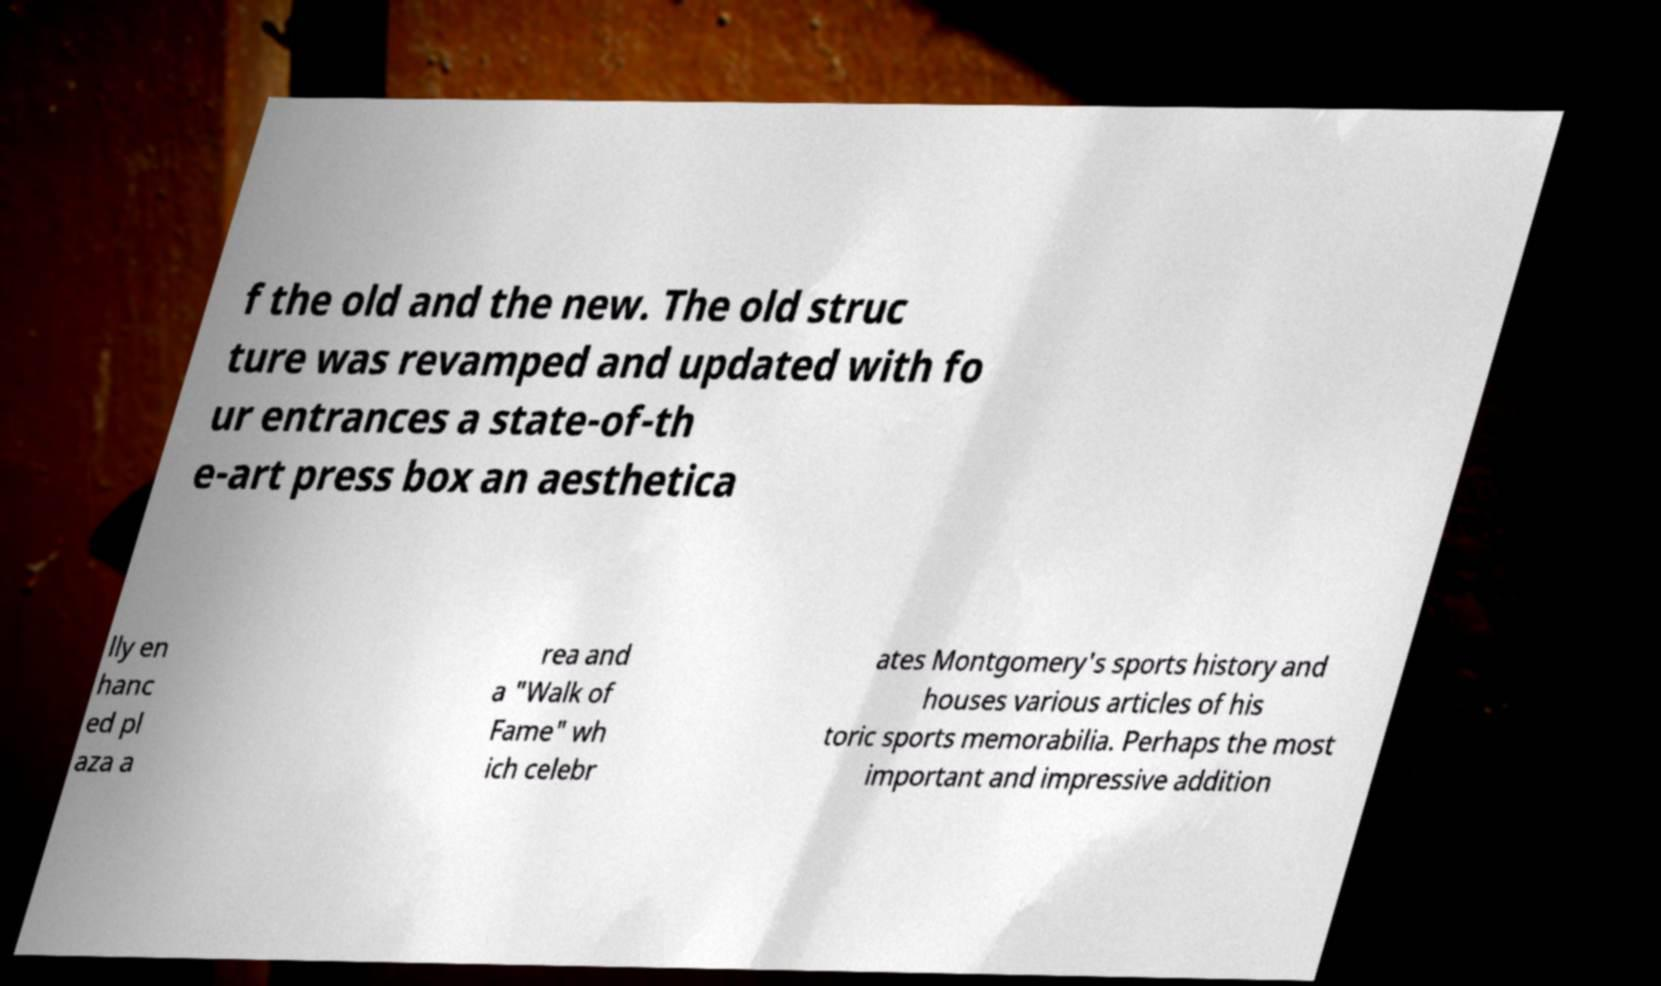There's text embedded in this image that I need extracted. Can you transcribe it verbatim? f the old and the new. The old struc ture was revamped and updated with fo ur entrances a state-of-th e-art press box an aesthetica lly en hanc ed pl aza a rea and a "Walk of Fame" wh ich celebr ates Montgomery's sports history and houses various articles of his toric sports memorabilia. Perhaps the most important and impressive addition 